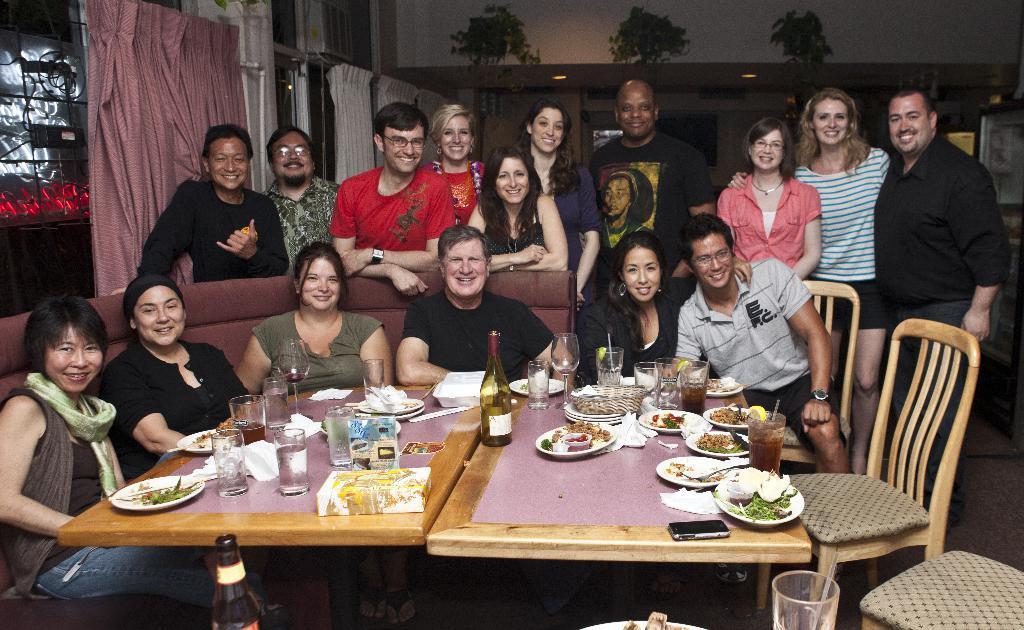How would you summarize this image in a sentence or two? There is a group of people. Some peoples are sitting and some peoples are standing. There is a table. There is a wine bottle,glass,mobile phone and some food products on the table. There is a chair or On the background we can see photo frames,wall and curtains,windows. On the right side we have a person. He's wearing a watch. 